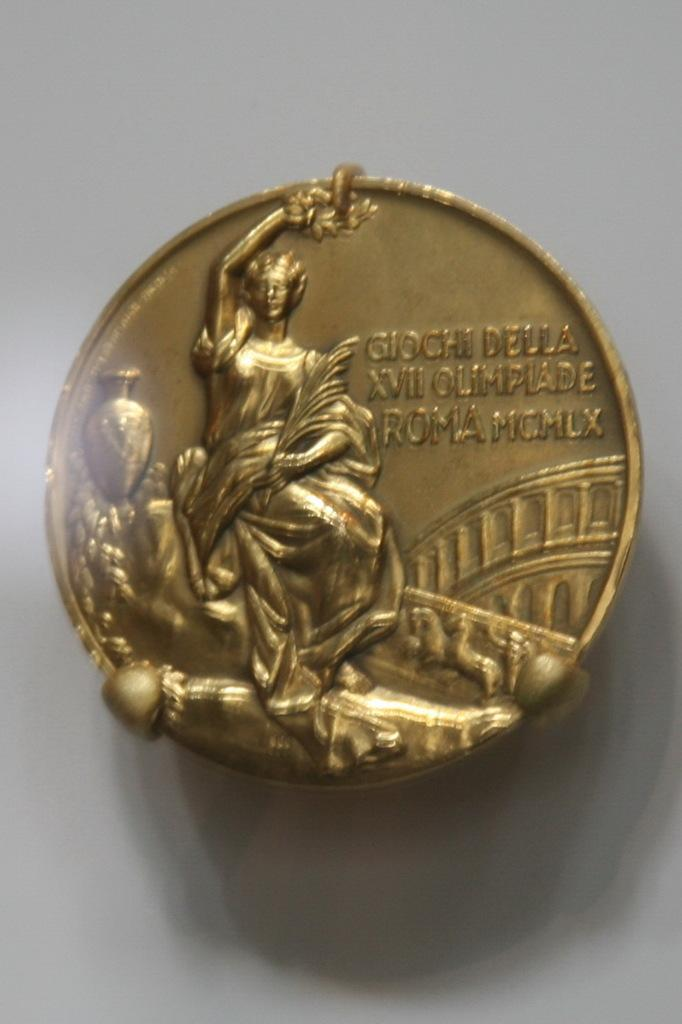What is the main object in the foreground of the image? There is a metal coin in the foreground of the image. What can be found on the metal coin? The metal coin has text on it, and there is a person's sculpture on it. What is visible in the background of the image? There is a wall visible in the background of the image. Can you describe the setting of the image? The image may have been taken in a room, as there is a wall visible in the background. How many worms can be seen crawling on the lumber in the image? There are no worms or lumber present in the image; it features a metal coin with a person's sculpture and text. What type of bucket is used to collect the water from the metal coin in the image? There is no bucket or water collection involved in the image; it simply shows a metal coin with a person's sculpture and text. 